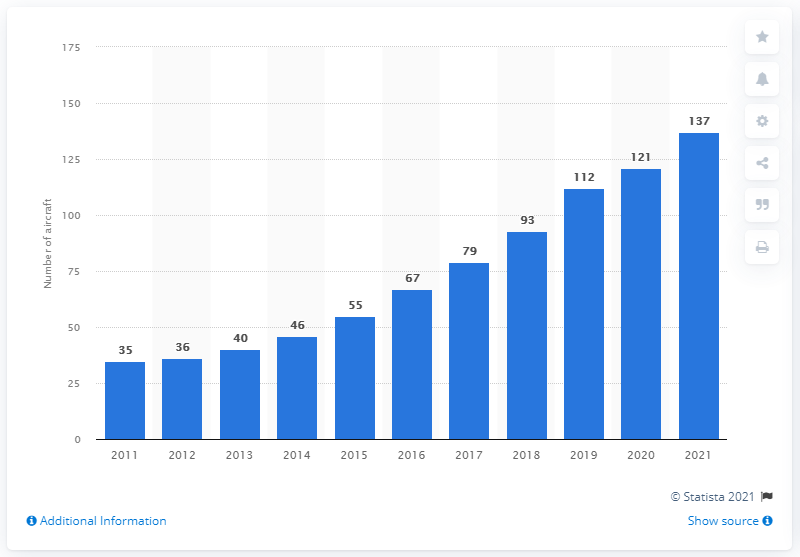Indicate a few pertinent items in this graphic. In 2021, Wizz Air had a fleet of 137 aircraft. 